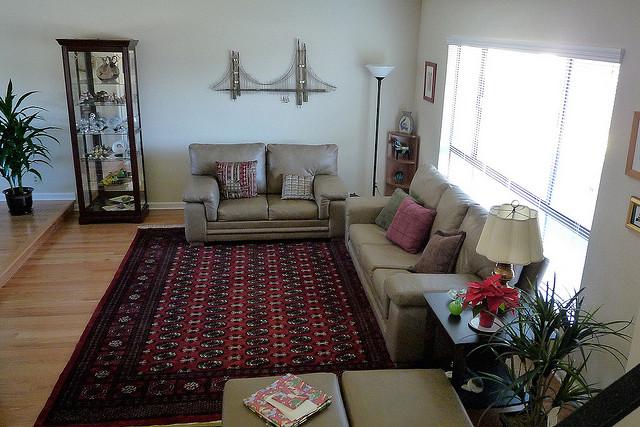How many different vases are there?
Short answer required. 2. How many pillows are on the two couches?
Answer briefly. 5. What color are the flowers?
Answer briefly. Red. What kind of flowers are in the vase?
Quick response, please. Roses. What holiday is this?
Write a very short answer. Christmas. Is there a water faucet in this room?
Concise answer only. No. How many people would fit in this area space?
Be succinct. 5. Does the furniture hold down the rug so it can't run away?
Answer briefly. No. How many shelves in the curio cabinet?
Give a very brief answer. 5. What is covering the seat of the chair?
Give a very brief answer. Pillows. How many rugs on there?
Keep it brief. 1. 